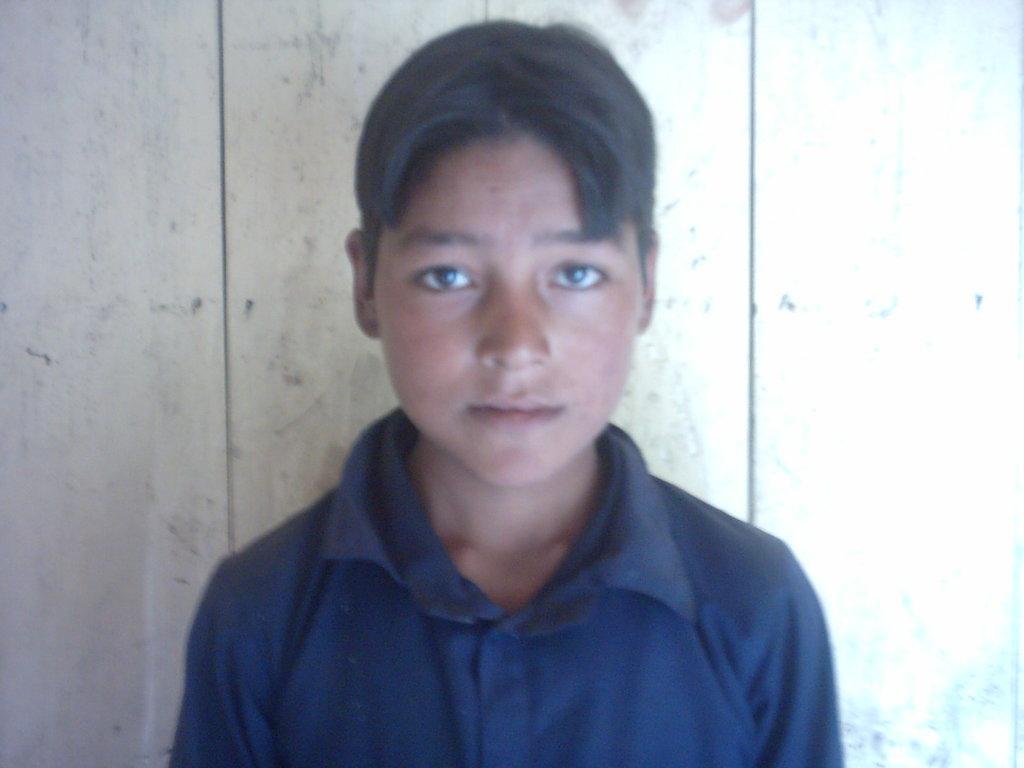How would you summarize this image in a sentence or two? In this picture there is a boy with navy blue t-shirt is standing. At the back there is a wooden wall. 